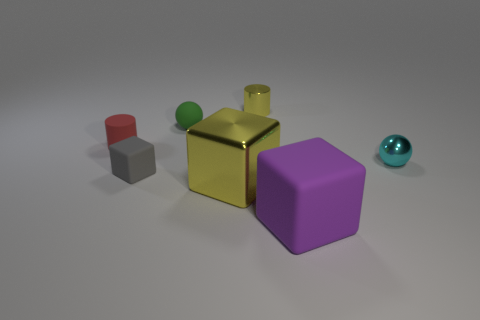Add 1 gray matte objects. How many objects exist? 8 Subtract all spheres. How many objects are left? 5 Add 1 tiny green balls. How many tiny green balls exist? 2 Subtract 0 brown cylinders. How many objects are left? 7 Subtract all small cyan metallic cylinders. Subtract all tiny metallic objects. How many objects are left? 5 Add 6 red things. How many red things are left? 7 